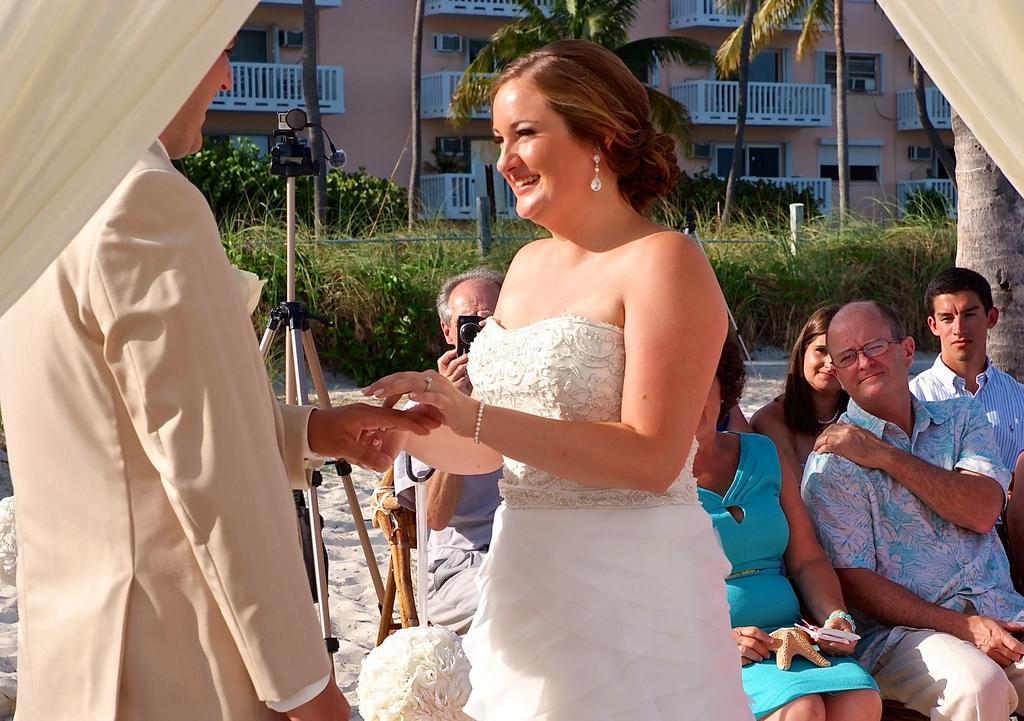Describe this image in one or two sentences. In this image there are few people in the sand in which one of them is holding a camera and taking a photo, there is a camera on the stand, there are few trees, plants and a fence. 